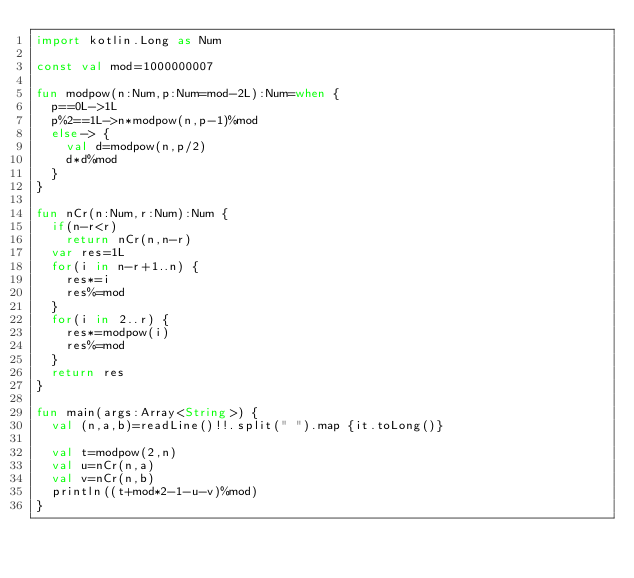Convert code to text. <code><loc_0><loc_0><loc_500><loc_500><_Kotlin_>import kotlin.Long as Num

const val mod=1000000007

fun modpow(n:Num,p:Num=mod-2L):Num=when {
	p==0L->1L
	p%2==1L->n*modpow(n,p-1)%mod
	else-> {
		val d=modpow(n,p/2)
		d*d%mod
	}
}

fun nCr(n:Num,r:Num):Num {
	if(n-r<r)
		return nCr(n,n-r)
	var res=1L
	for(i in n-r+1..n) {
		res*=i
		res%=mod
	}
	for(i in 2..r) {
		res*=modpow(i)
		res%=mod
	}
	return res
}

fun main(args:Array<String>) {
	val (n,a,b)=readLine()!!.split(" ").map {it.toLong()}

	val t=modpow(2,n)
	val u=nCr(n,a)
	val v=nCr(n,b)
	println((t+mod*2-1-u-v)%mod)
}
</code> 